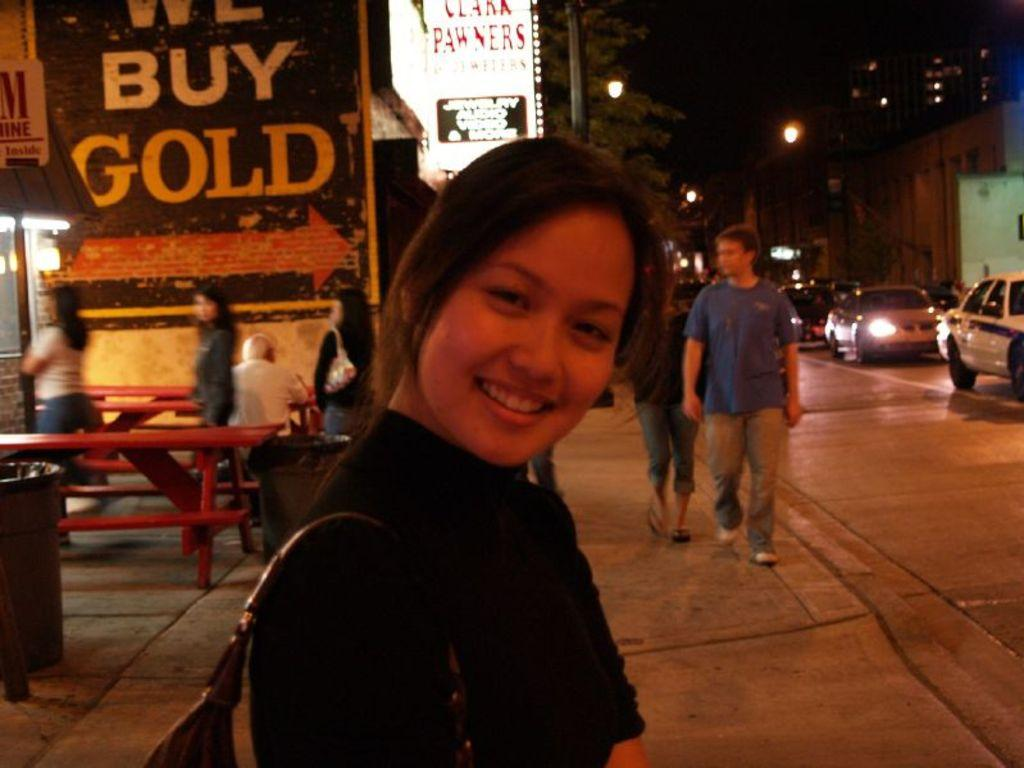Who is present in the image? There is a woman in the image. What is the woman doing in the image? The woman is smiling in the image. What is the woman wearing in the image? The woman is wearing a bag in the image. What can be seen in the background of the image? There are people, vehicles, a bench, a table, a dustbin, trees, and light-poles visible in the background. What type of industry can be seen in the background of the image? There is no industry present in the image; it features a woman smiling and various objects in the background. Can you tell me how many people are helping the woman in the image? There is no indication in the image that the woman is receiving help from anyone. 